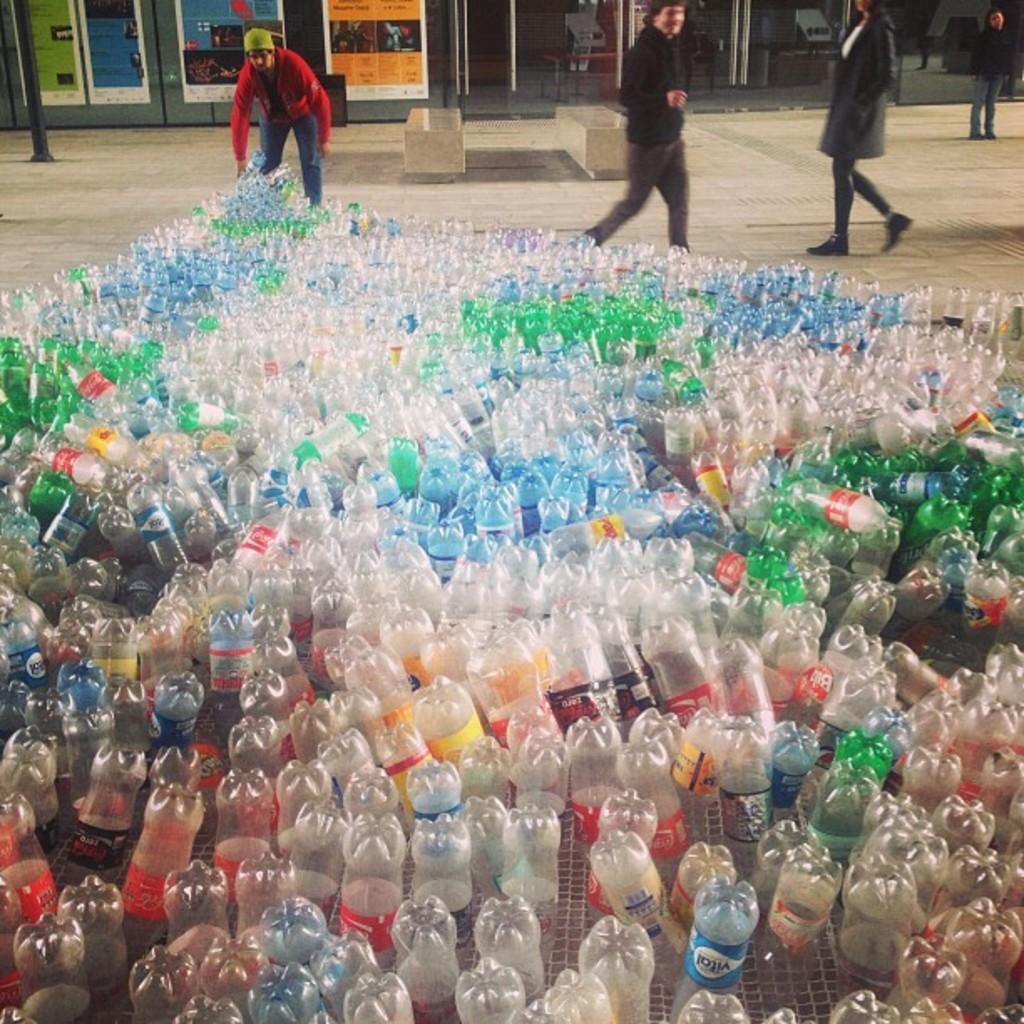Can you describe this image briefly? In the foreground of the image, plastic bottles are kept on the floor. In the left, a person is standing and holding a bottle. And in the right three persons are standing. In the background , there are shops visible. This image is taken during day time. 